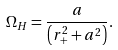<formula> <loc_0><loc_0><loc_500><loc_500>\Omega _ { H } = \frac { a } { \left ( r _ { + } ^ { 2 } + a ^ { 2 } \right ) } .</formula> 